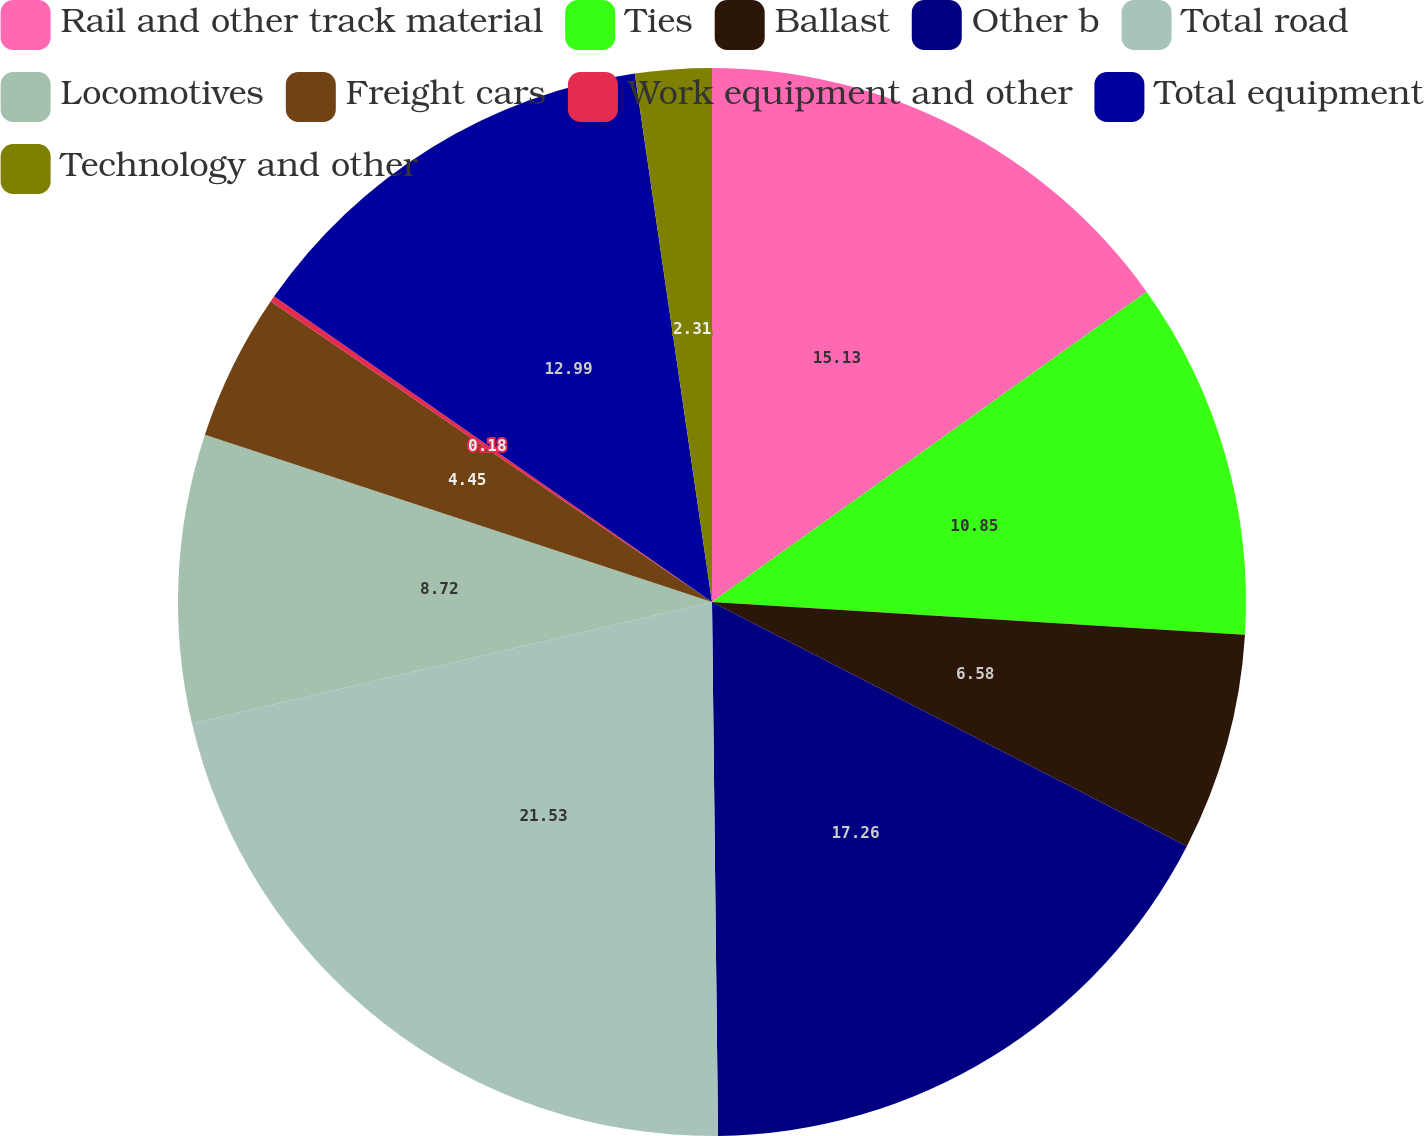<chart> <loc_0><loc_0><loc_500><loc_500><pie_chart><fcel>Rail and other track material<fcel>Ties<fcel>Ballast<fcel>Other b<fcel>Total road<fcel>Locomotives<fcel>Freight cars<fcel>Work equipment and other<fcel>Total equipment<fcel>Technology and other<nl><fcel>15.13%<fcel>10.85%<fcel>6.58%<fcel>17.26%<fcel>21.53%<fcel>8.72%<fcel>4.45%<fcel>0.18%<fcel>12.99%<fcel>2.31%<nl></chart> 